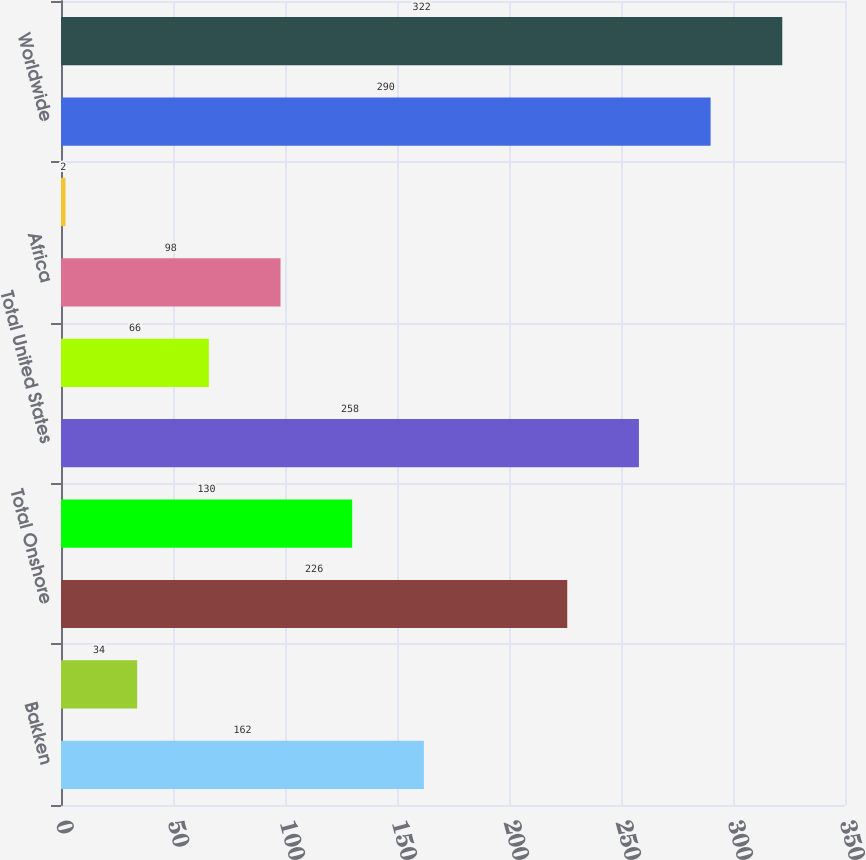Convert chart. <chart><loc_0><loc_0><loc_500><loc_500><bar_chart><fcel>Bakken<fcel>Other Onshore<fcel>Total Onshore<fcel>Offshore<fcel>Total United States<fcel>Europe<fcel>Africa<fcel>Asia<fcel>Worldwide<fcel>Barrels of Oil Equivalent<nl><fcel>162<fcel>34<fcel>226<fcel>130<fcel>258<fcel>66<fcel>98<fcel>2<fcel>290<fcel>322<nl></chart> 